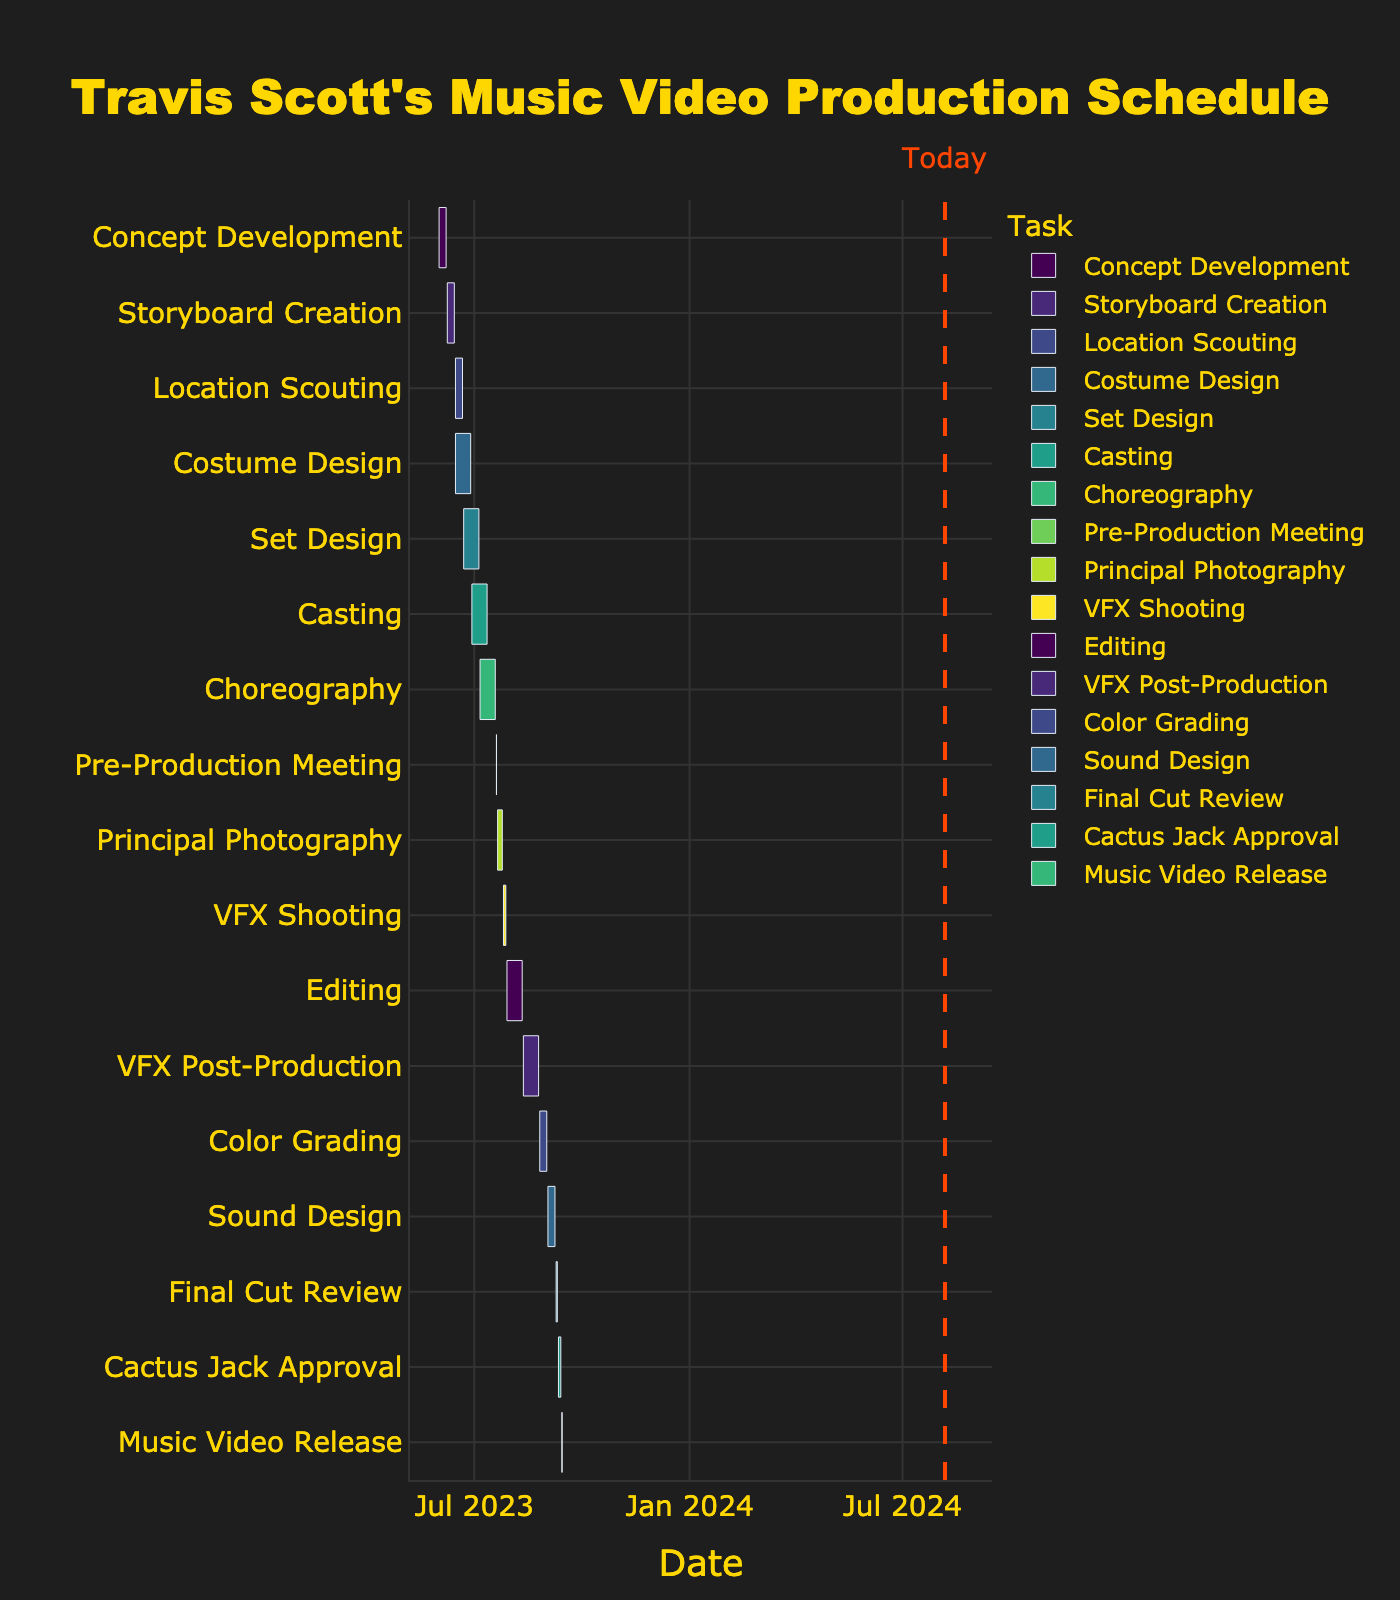What is the duration of the 'Principal Photography' task? The start date for Principal Photography is 2023-07-21, and the end date is 2023-07-25. Calculating the difference, the duration is 4 days.
Answer: 4 days Which task has the longest duration? By comparing the duration of all tasks, 'Costume Design' runs from 2023-06-15 to 2023-06-28, giving a duration of 13 days, which is the longest.
Answer: Costume Design When is the 'Pre-Production Meeting' scheduled? The 'Pre-Production Meeting' is set for a single day on 2023-07-20.
Answer: 2023-07-20 Which task starts right after the 'Set Design' ends? The 'Set Design' ends on 2023-07-05. The next task starting is 'Casting' on 2023-07-06.
Answer: Casting What is the total time taken from 'Concept Development' to 'Cactus Jack Approval'? 'Concept Development' starts on 2023-06-01, and 'Cactus Jack Approval' ends on 2023-09-13. The total span is from June 1 to September 13. Calculating the total duration gives 104 days.
Answer: 104 days How long is the 'Editing' process compared to the 'VFX Post-Production' process? 'Editing' starts on 2023-07-29 and ends on 2023-08-11, providing 13 days. 'VFX Post-Production' starts on 2023-08-12 and ends on 2023-08-25, also lasting 13 days. Therefore, both processes take the same amount of time.
Answer: Same duration Which tasks are overlapping on June 15, 2023? On June 15, 'Location Scouting' starts and 'Costume Design' also begins on the same date.
Answer: Location Scouting and Costume Design When does the 'Music Video Release' happen? The 'Music Video Release' is scheduled for a single day on 2023-09-14.
Answer: 2023-09-14 Which task ends right before 'Principal Photography' starts? 'Pre-Production Meeting' ends on 2023-07-20, which is right before 'Principal Photography' starts on 2023-07-21.
Answer: Pre-Production Meeting 